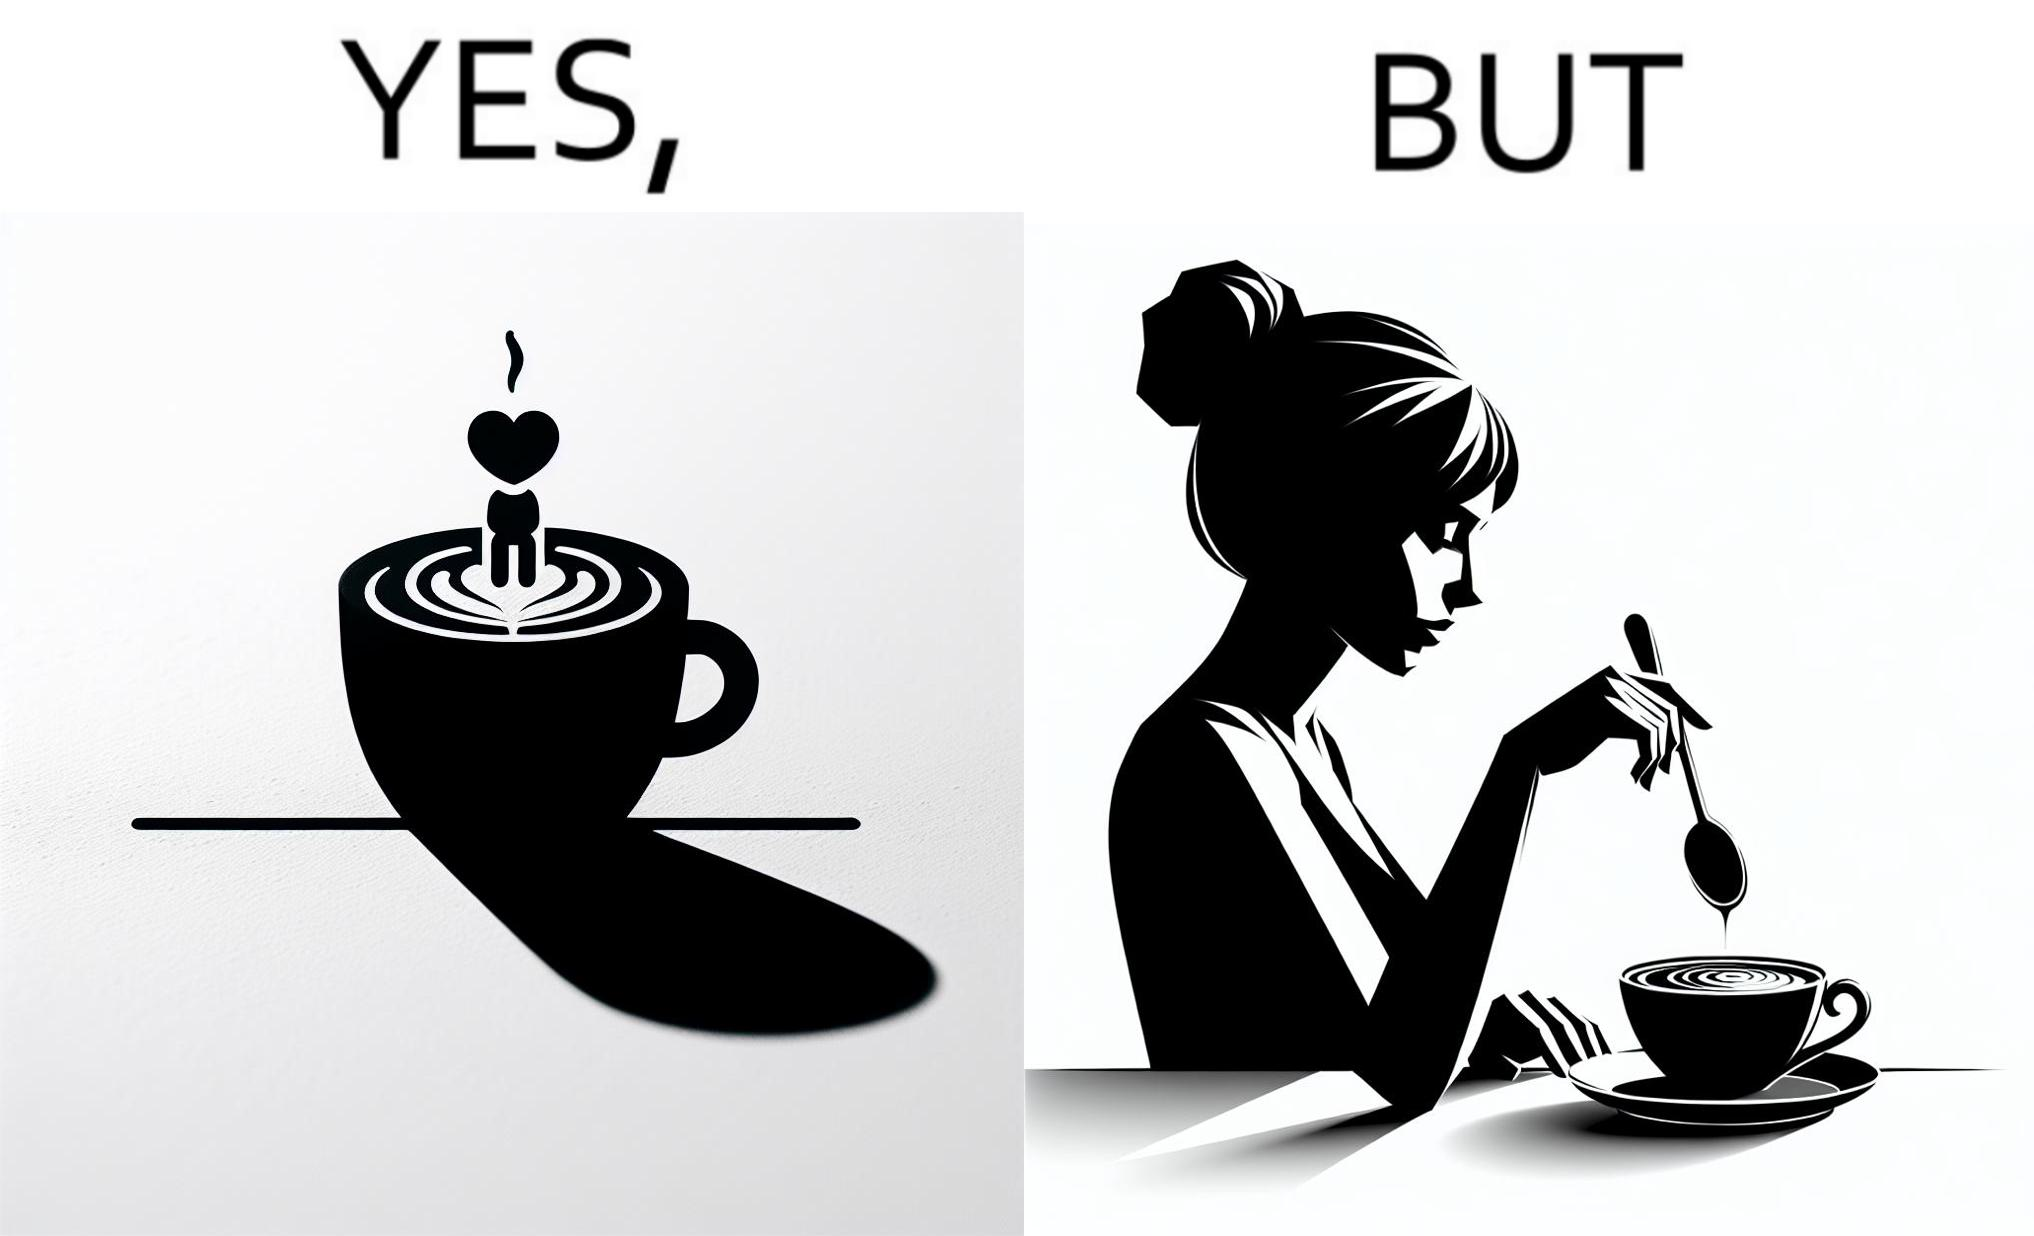Describe what you see in this image. The image is ironic, because even when the coffee maker create latte art to make coffee look attractive but it is there just for a short time after that it is vanished 